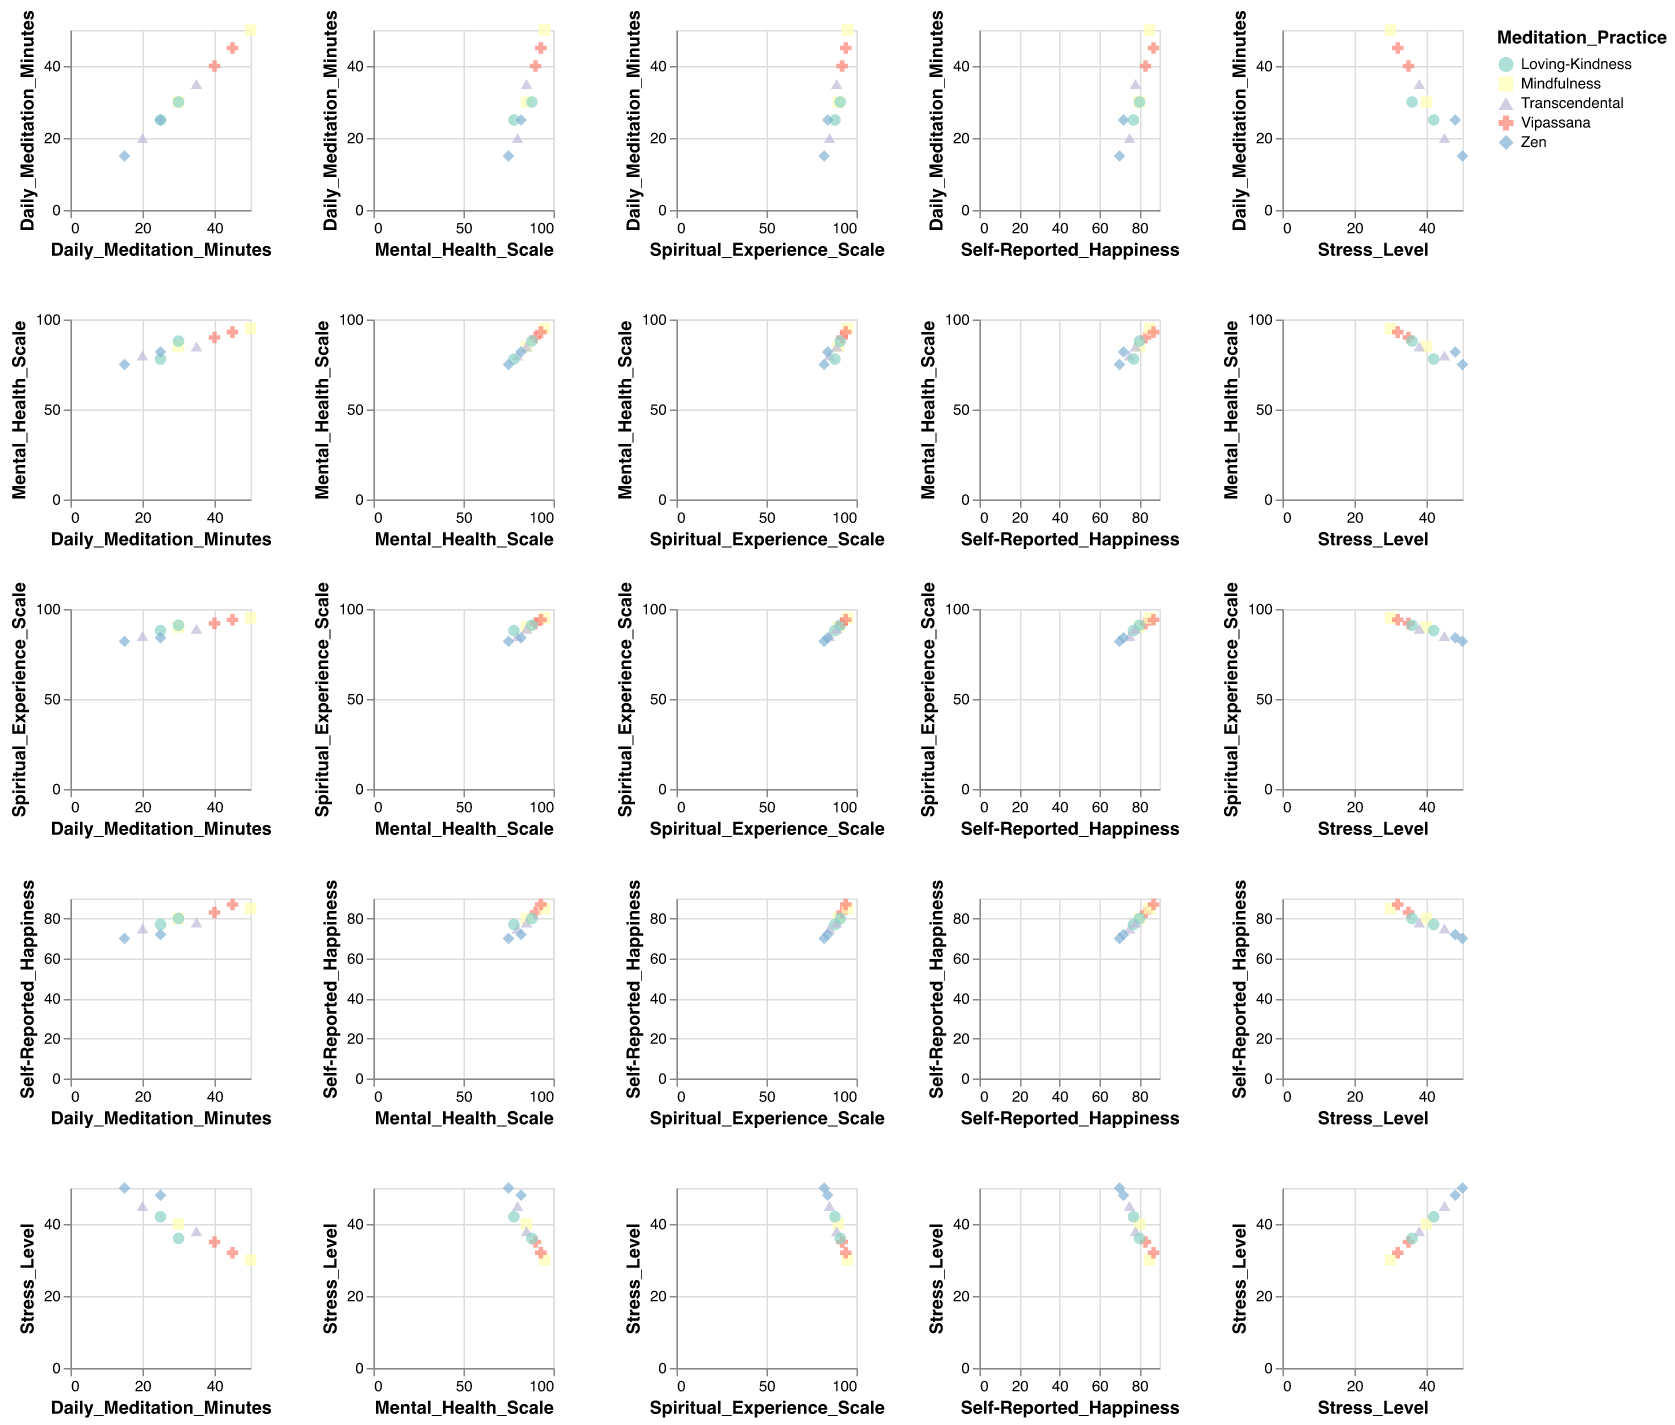How many data points are shown in the scatter plot matrix? There are 10 distinct data points corresponding to 10 different meditation practice entries in the dataset. Each entry appears once in the scatter plot matrix.
Answer: 10 How is the "Stress Level" related to "Self-Reported Happiness"? By examining the scatter plot corresponding to "Stress Level" vs "Self-Reported Happiness", we see that as the "Self-Reported Happiness" increases, the "Stress Level" generally decreases, suggesting an inverse relationship.
Answer: Inversely related Which meditation practice exhibits the highest "Daily Meditation Minutes"? By identifying the maximum value in the "Daily Meditation Minutes" axis across all points, we find that "Mindfulness" has the highest value at 50 minutes.
Answer: Mindfulness What is the relationship between "Daily Meditation Minutes" and "Mental Health Scale"? Observing the scatter plot with "Daily Meditation Minutes" on the x-axis and "Mental Health Scale" on the y-axis, there appears to be a positive correlation, where higher daily meditation minutes are associated with a higher mental health scale.
Answer: Positive correlation Average "Mental Health Scale" of practices with more than 30 "Daily Meditation Minutes"? Only including entries with more than 30 "Daily Meditation Minutes" (Mindfulness - 50, Vipassana - 40 and 45, Transcendental - 35), their mental health scale values are 95, 90, 93, and 85. The average is (95 + 90 + 93 + 85) / 4 = 90.75.
Answer: 90.75 Between "Zen" and "Vipassana", which practice tends to have lower "Stress Level"? By comparing the "Stress Level" data points for "Zen" (50 and 48) and "Vipassana" (35 and 32), Vipassana has noticeably lower stress levels.
Answer: Vipassana Which meditation practice tends to show the highest "Spiritual Experience Scale"? Looking at the "Spiritual Experience Scale" for each practice, the highest values are for "Mindfulness" (90, 95) and "Vipassana" (92, 94) with 95 being the highest overall, suggesting Mindfulness shows the highest scale.
Answer: Mindfulness Do any meditation practices exhibit equal "Daily Meditation Minutes" and "Mental Health Scale"? By comparing the values, we find that no meditation practice has a matching set of values where "Daily Meditation Minutes" are equal to "Mental Health Scale".
Answer: No Which pair of metrics exhibits the weakest correlation in this dataset? By comparing scatter plots across multiple pairs, the weaskest correlations appears between "Daily Meditation Minutes" and "Self-Reported Happiness" with no clear pattern between these metrics.
Answer: Daily Meditation Minutes and Self-Reported Happiness 